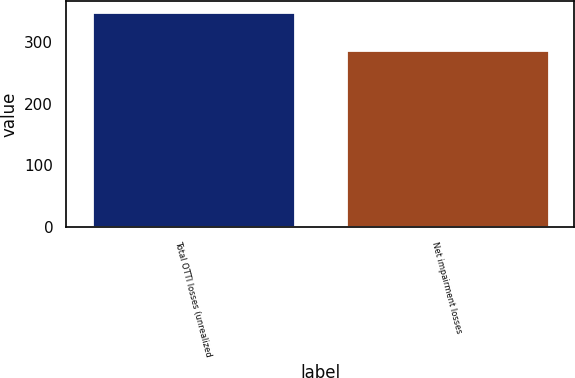<chart> <loc_0><loc_0><loc_500><loc_500><bar_chart><fcel>Total OTTI losses (unrealized<fcel>Net impairment losses<nl><fcel>348<fcel>287<nl></chart> 